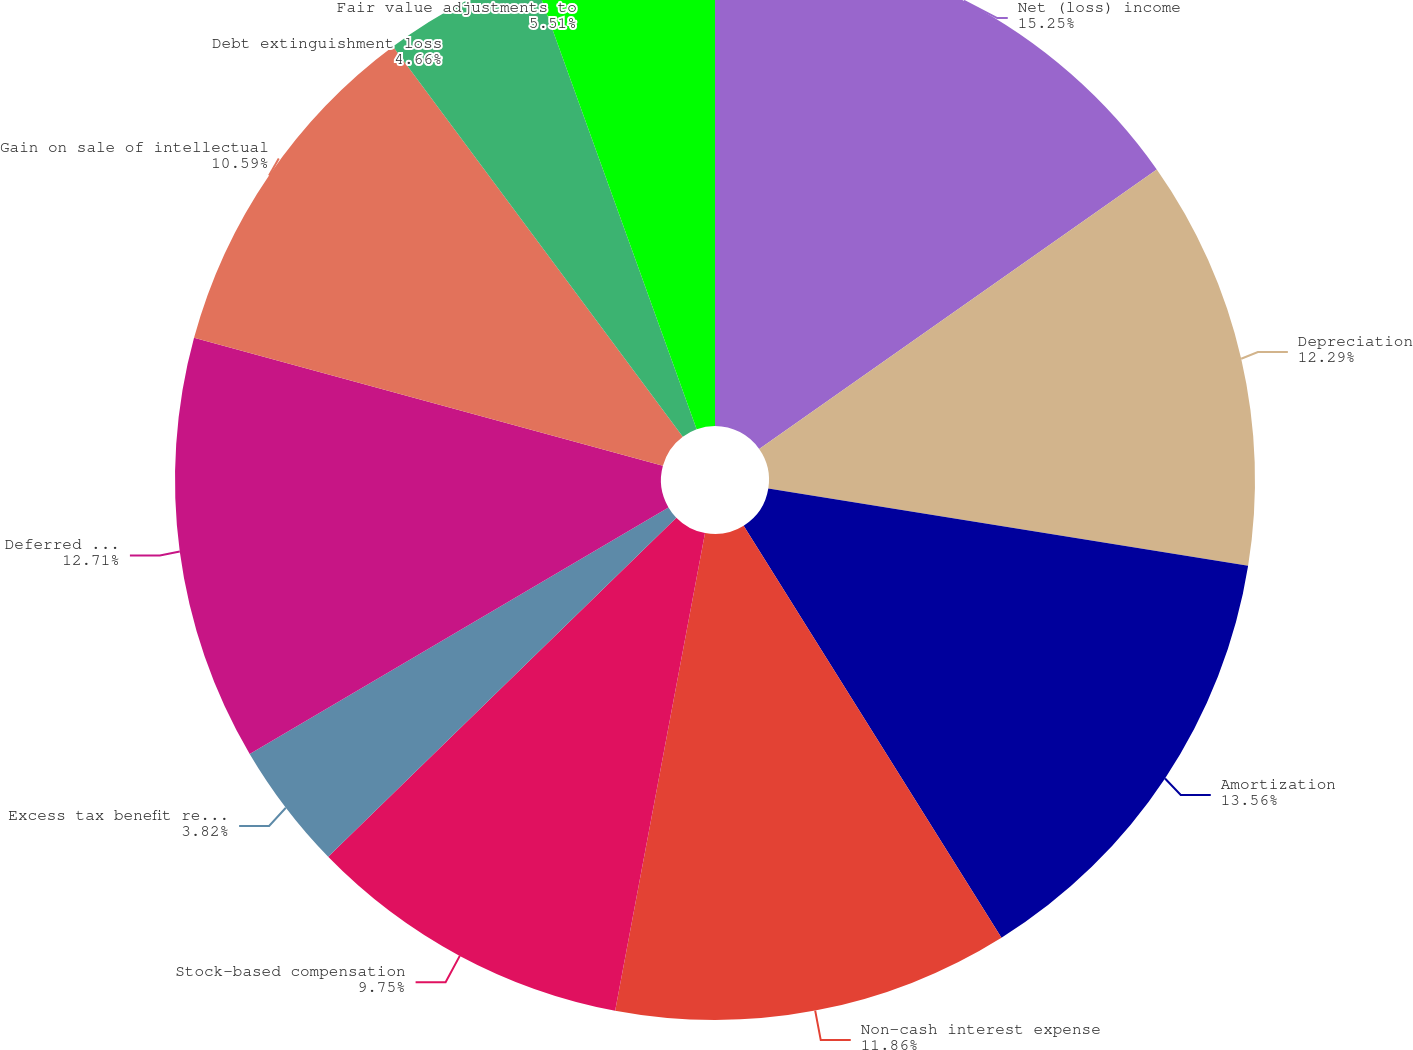<chart> <loc_0><loc_0><loc_500><loc_500><pie_chart><fcel>Net (loss) income<fcel>Depreciation<fcel>Amortization<fcel>Non-cash interest expense<fcel>Stock-based compensation<fcel>Excess tax benefit related to<fcel>Deferred income taxes<fcel>Gain on sale of intellectual<fcel>Debt extinguishment loss<fcel>Fair value adjustments to<nl><fcel>15.25%<fcel>12.29%<fcel>13.56%<fcel>11.86%<fcel>9.75%<fcel>3.82%<fcel>12.71%<fcel>10.59%<fcel>4.66%<fcel>5.51%<nl></chart> 